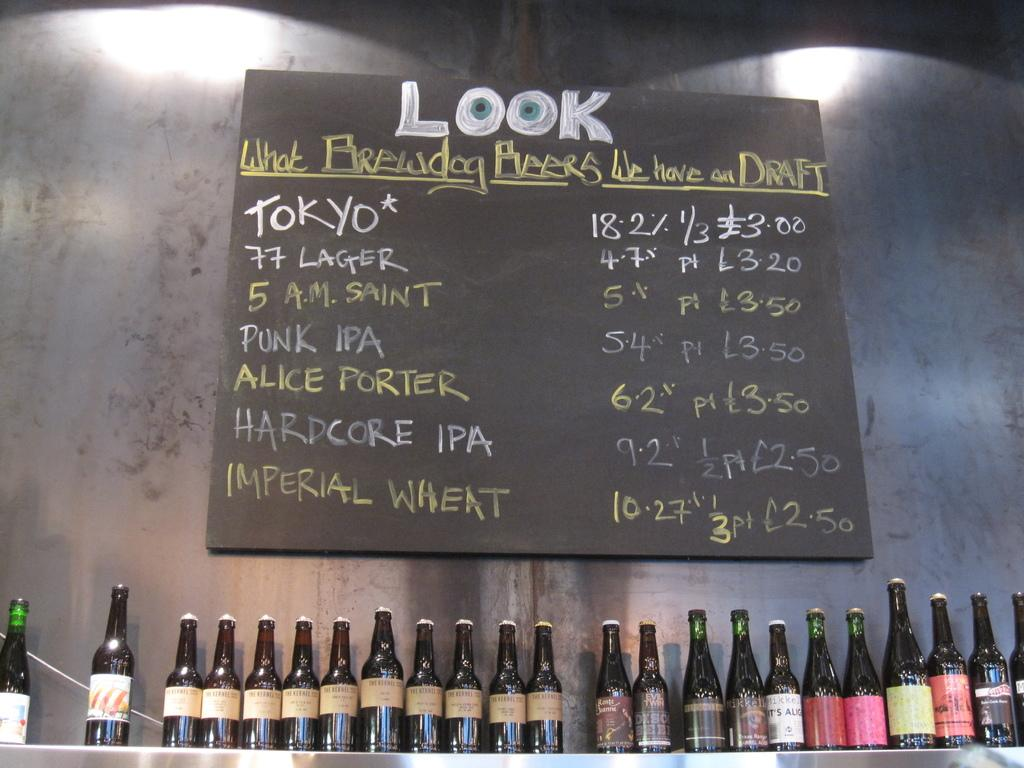What is the primary subject of the image? The primary subject of the image is many wine bottles. Can you describe any other objects or features in the image? Yes, there is a board on the wall in the image. What type of hair can be seen on the plate in the image? There is no plate or hair present in the image. 